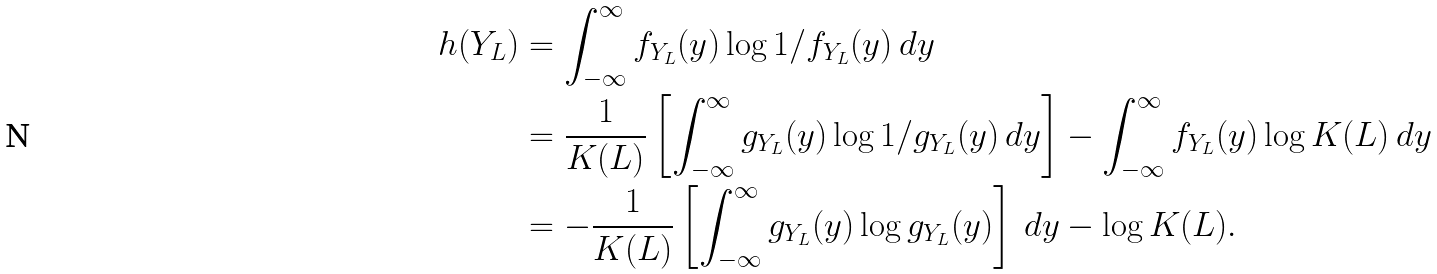<formula> <loc_0><loc_0><loc_500><loc_500>h ( Y _ { L } ) & = \int _ { - \infty } ^ { \infty } f _ { Y _ { L } } ( y ) \log 1 / f _ { Y _ { L } } ( y ) \, d y \\ & = \frac { 1 } { K ( L ) } \left [ \int _ { - \infty } ^ { \infty } g _ { Y _ { L } } ( y ) \log 1 / g _ { Y _ { L } } ( y ) \, d y \right ] - \int _ { - \infty } ^ { \infty } f _ { Y _ { L } } ( y ) \log K ( L ) \, d y \\ & = - \frac { 1 } { K ( L ) } \left [ \int _ { - \infty } ^ { \infty } g _ { Y _ { L } } ( y ) \log g _ { Y _ { L } } ( y ) \right ] \, d y - \log K ( L ) .</formula> 